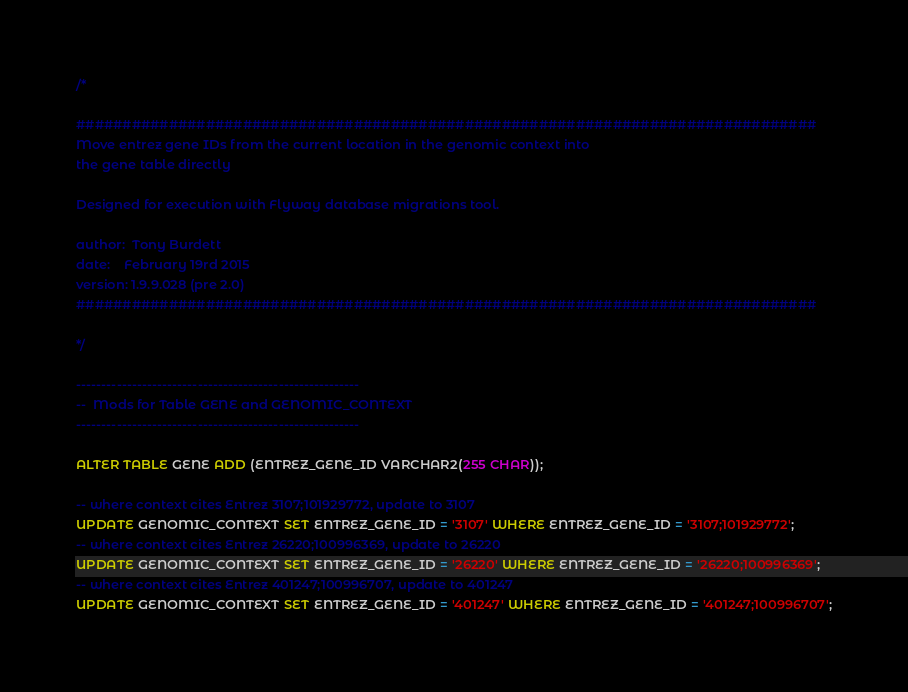<code> <loc_0><loc_0><loc_500><loc_500><_SQL_>/*

################################################################################
Move entrez gene IDs from the current location in the genomic context into
the gene table directly

Designed for execution with Flyway database migrations tool.

author:  Tony Burdett
date:    February 19rd 2015
version: 1.9.9.028 (pre 2.0)
################################################################################

*/

--------------------------------------------------------
--  Mods for Table GENE and GENOMIC_CONTEXT
--------------------------------------------------------

ALTER TABLE GENE ADD (ENTREZ_GENE_ID VARCHAR2(255 CHAR));

-- where context cites Entrez 3107;101929772, update to 3107
UPDATE GENOMIC_CONTEXT SET ENTREZ_GENE_ID = '3107' WHERE ENTREZ_GENE_ID = '3107;101929772';
-- where context cites Entrez 26220;100996369, update to 26220
UPDATE GENOMIC_CONTEXT SET ENTREZ_GENE_ID = '26220' WHERE ENTREZ_GENE_ID = '26220;100996369';
-- where context cites Entrez 401247;100996707, update to 401247
UPDATE GENOMIC_CONTEXT SET ENTREZ_GENE_ID = '401247' WHERE ENTREZ_GENE_ID = '401247;100996707';
</code> 